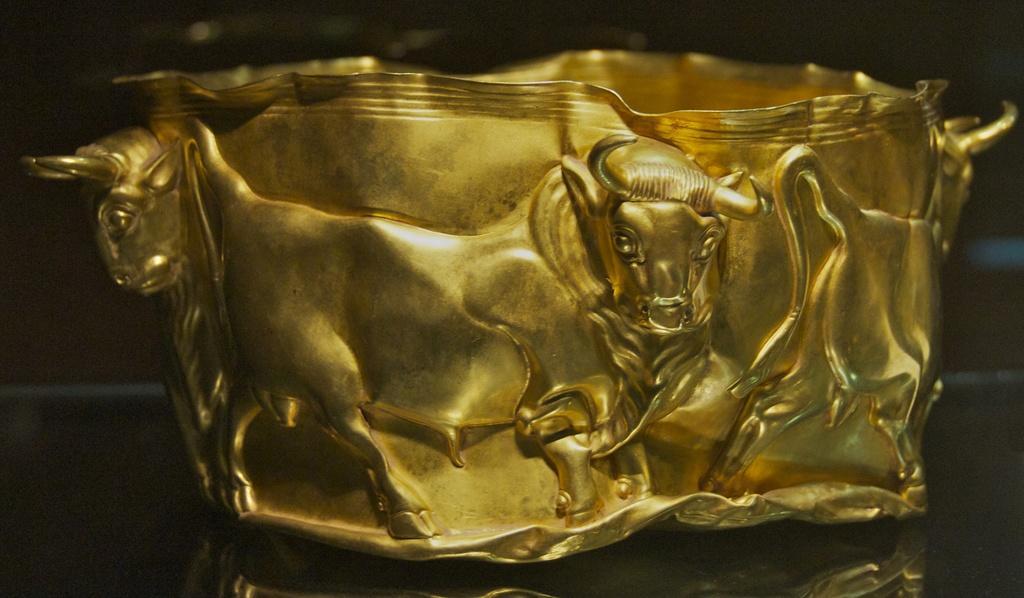Describe this image in one or two sentences. This looks like a metal object with gold color. I can see the design of the bulls on the metal. 